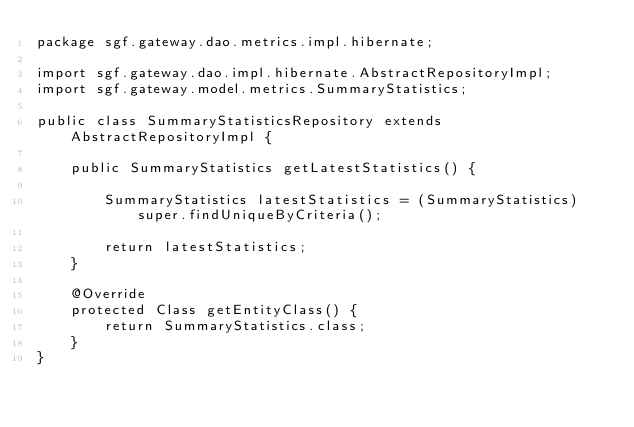Convert code to text. <code><loc_0><loc_0><loc_500><loc_500><_Java_>package sgf.gateway.dao.metrics.impl.hibernate;

import sgf.gateway.dao.impl.hibernate.AbstractRepositoryImpl;
import sgf.gateway.model.metrics.SummaryStatistics;

public class SummaryStatisticsRepository extends AbstractRepositoryImpl {

    public SummaryStatistics getLatestStatistics() {

        SummaryStatistics latestStatistics = (SummaryStatistics) super.findUniqueByCriteria();

        return latestStatistics;
    }

    @Override
    protected Class getEntityClass() {
        return SummaryStatistics.class;
    }
}
</code> 